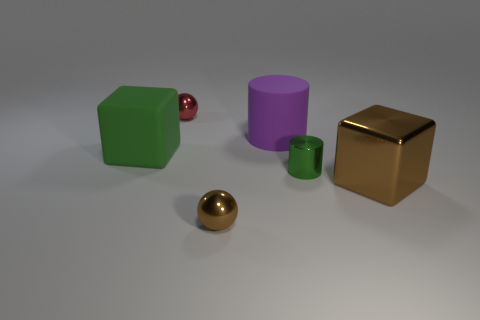Are the cylinder to the left of the small green metallic object and the tiny sphere in front of the green metal object made of the same material?
Provide a succinct answer. No. There is a red metallic thing; what shape is it?
Give a very brief answer. Sphere. Are there more metallic balls behind the rubber block than brown blocks that are left of the large brown block?
Your answer should be compact. Yes. Is the shape of the green object that is to the right of the brown ball the same as the big purple thing behind the tiny cylinder?
Offer a terse response. Yes. What number of other things are the same size as the red ball?
Keep it short and to the point. 2. What size is the purple cylinder?
Provide a short and direct response. Large. Does the small object that is on the right side of the brown ball have the same material as the brown sphere?
Keep it short and to the point. Yes. There is another big object that is the same shape as the green rubber thing; what color is it?
Your answer should be very brief. Brown. There is a block that is behind the big metallic thing; does it have the same color as the tiny shiny cylinder?
Your answer should be very brief. Yes. Are there any tiny brown metal spheres in front of the big green rubber thing?
Provide a succinct answer. Yes. 